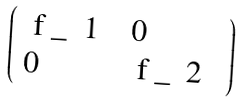Convert formula to latex. <formula><loc_0><loc_0><loc_500><loc_500>\left ( \begin{array} { l l } $ f _ { 1 } $ & 0 \\ 0 & $ f _ { 2 } $ \end{array} \right )</formula> 